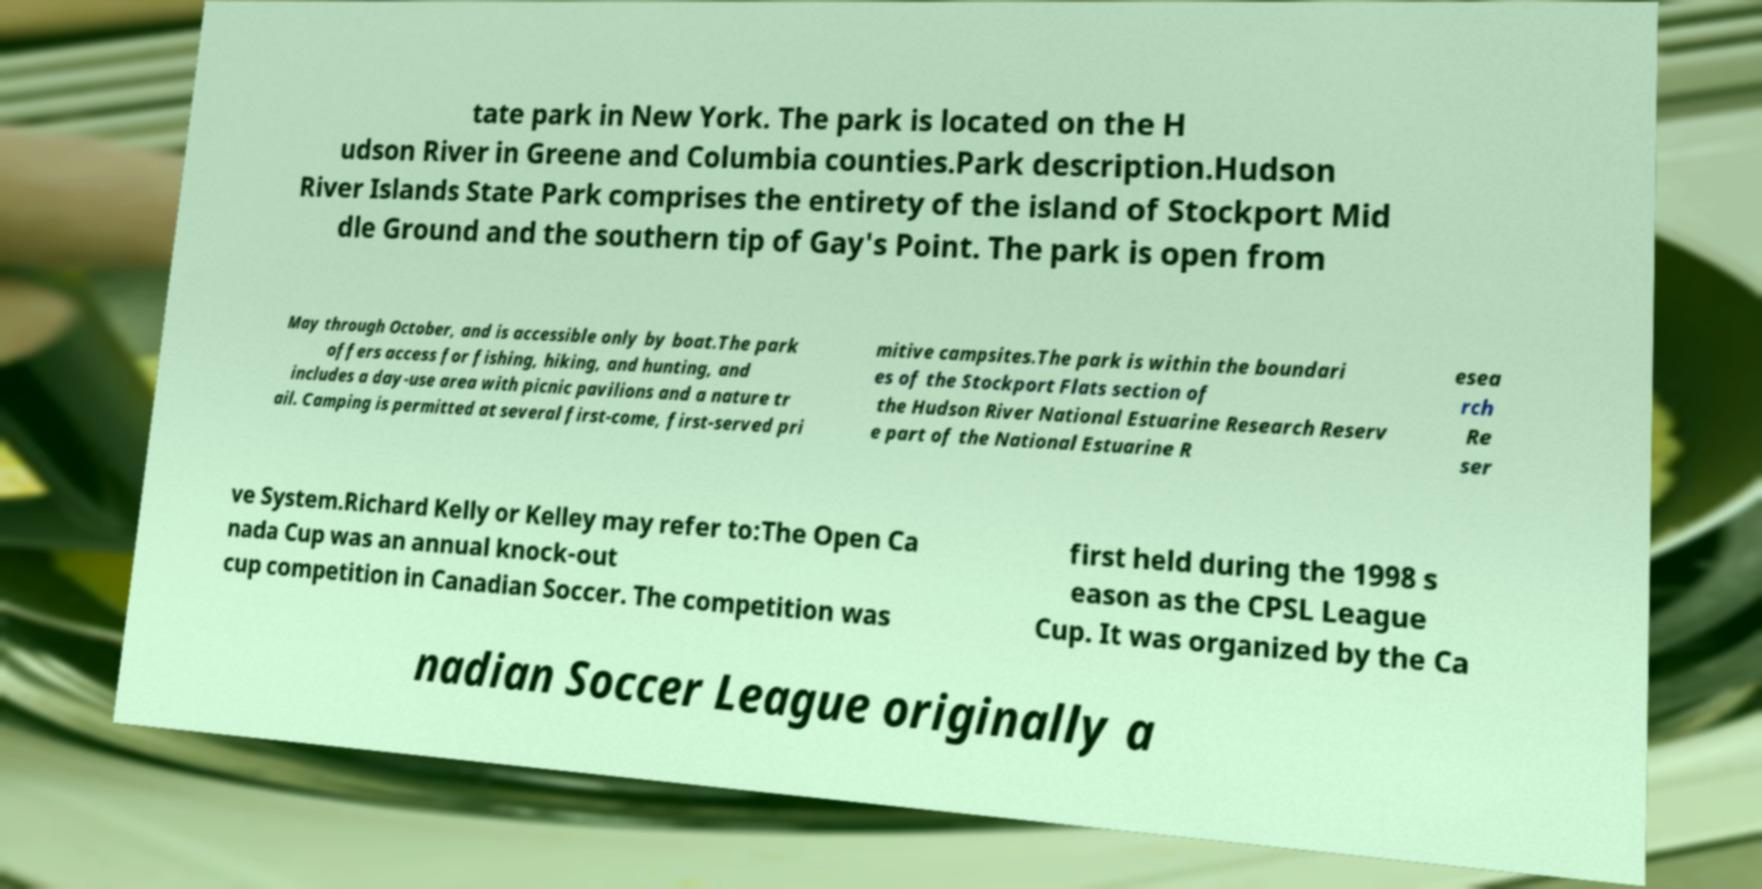Please identify and transcribe the text found in this image. tate park in New York. The park is located on the H udson River in Greene and Columbia counties.Park description.Hudson River Islands State Park comprises the entirety of the island of Stockport Mid dle Ground and the southern tip of Gay's Point. The park is open from May through October, and is accessible only by boat.The park offers access for fishing, hiking, and hunting, and includes a day-use area with picnic pavilions and a nature tr ail. Camping is permitted at several first-come, first-served pri mitive campsites.The park is within the boundari es of the Stockport Flats section of the Hudson River National Estuarine Research Reserv e part of the National Estuarine R esea rch Re ser ve System.Richard Kelly or Kelley may refer to:The Open Ca nada Cup was an annual knock-out cup competition in Canadian Soccer. The competition was first held during the 1998 s eason as the CPSL League Cup. It was organized by the Ca nadian Soccer League originally a 